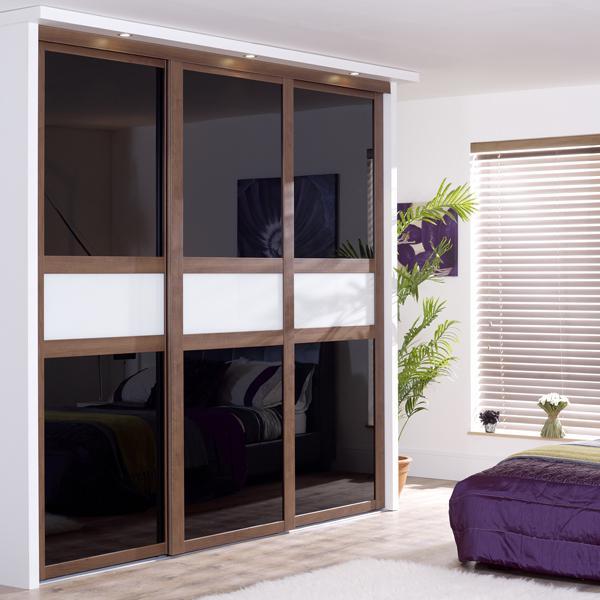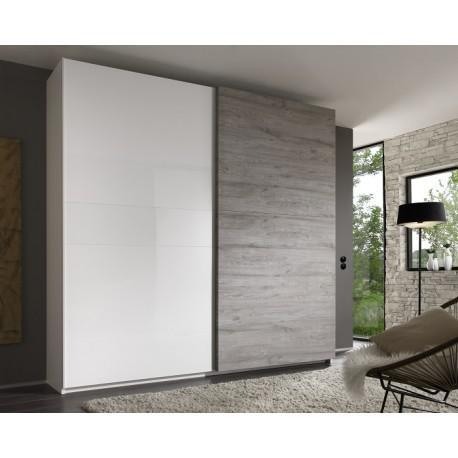The first image is the image on the left, the second image is the image on the right. Analyze the images presented: Is the assertion "there is a closet with a curtained window on the wall to the right" valid? Answer yes or no. No. 